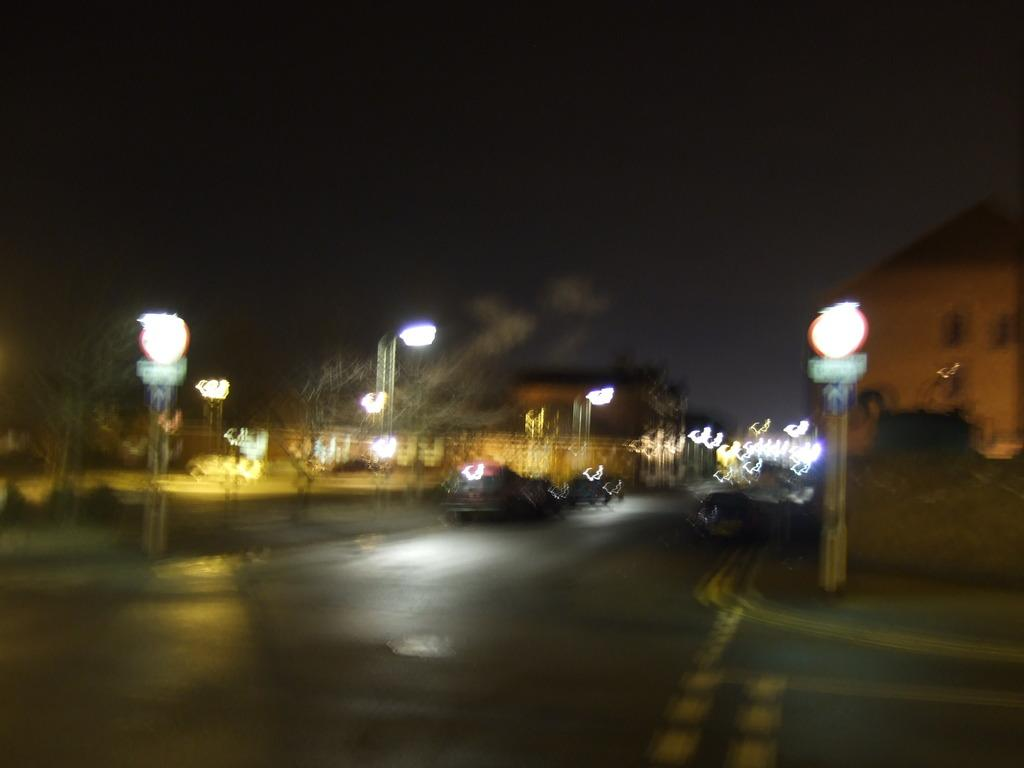What is the lighting condition in the image? The image was taken in the dark. What can be seen on the road in the image? There are cars on the road in the image. What is present on both sides of the road in the image? There are street lights on both sides of the road in the image. What is the size of the raindrops in the image? There is no rain present in the image, so the size of raindrops cannot be determined. 